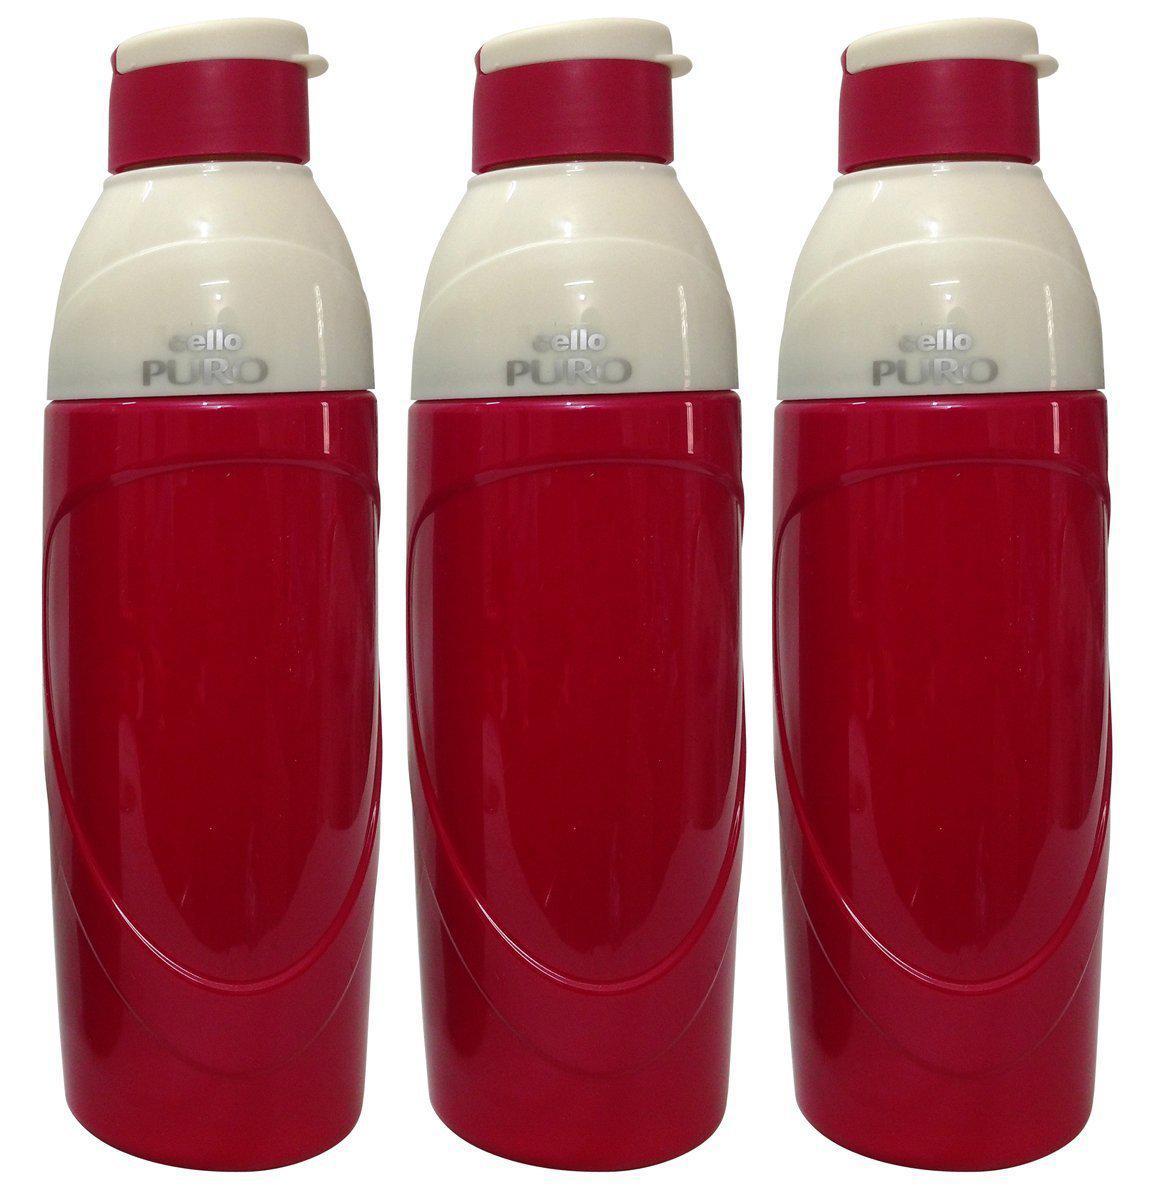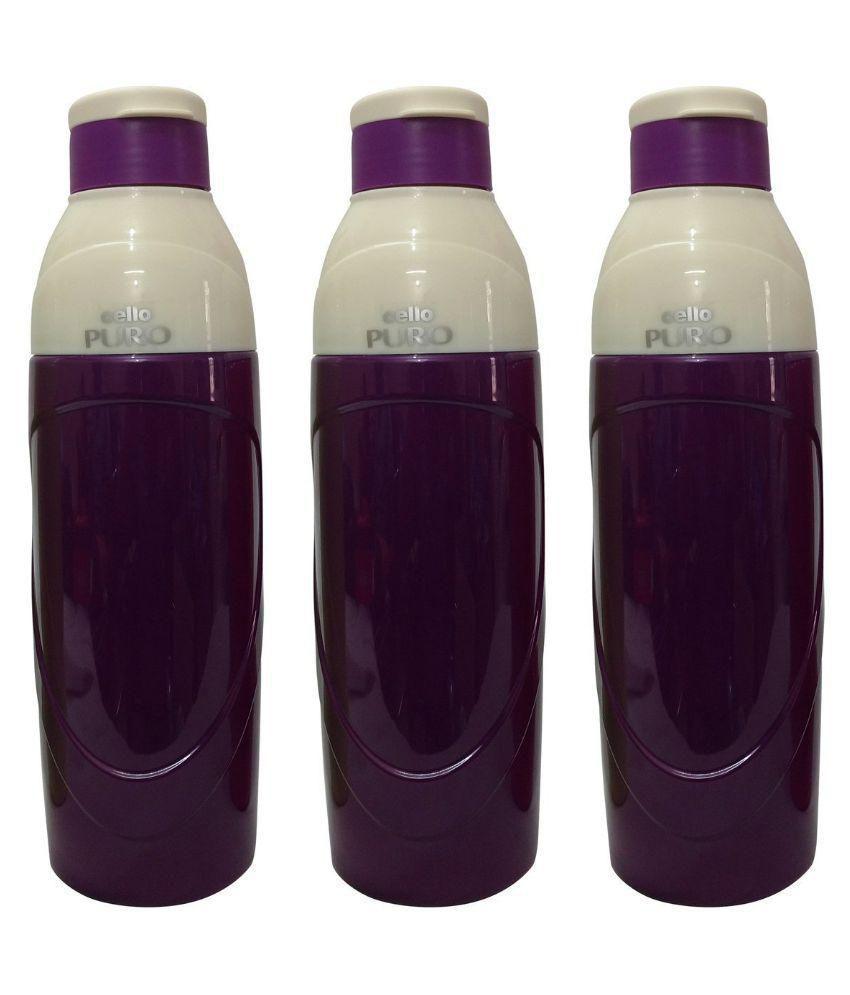The first image is the image on the left, the second image is the image on the right. Analyze the images presented: Is the assertion "There are exactly 10 bottles" valid? Answer yes or no. No. 